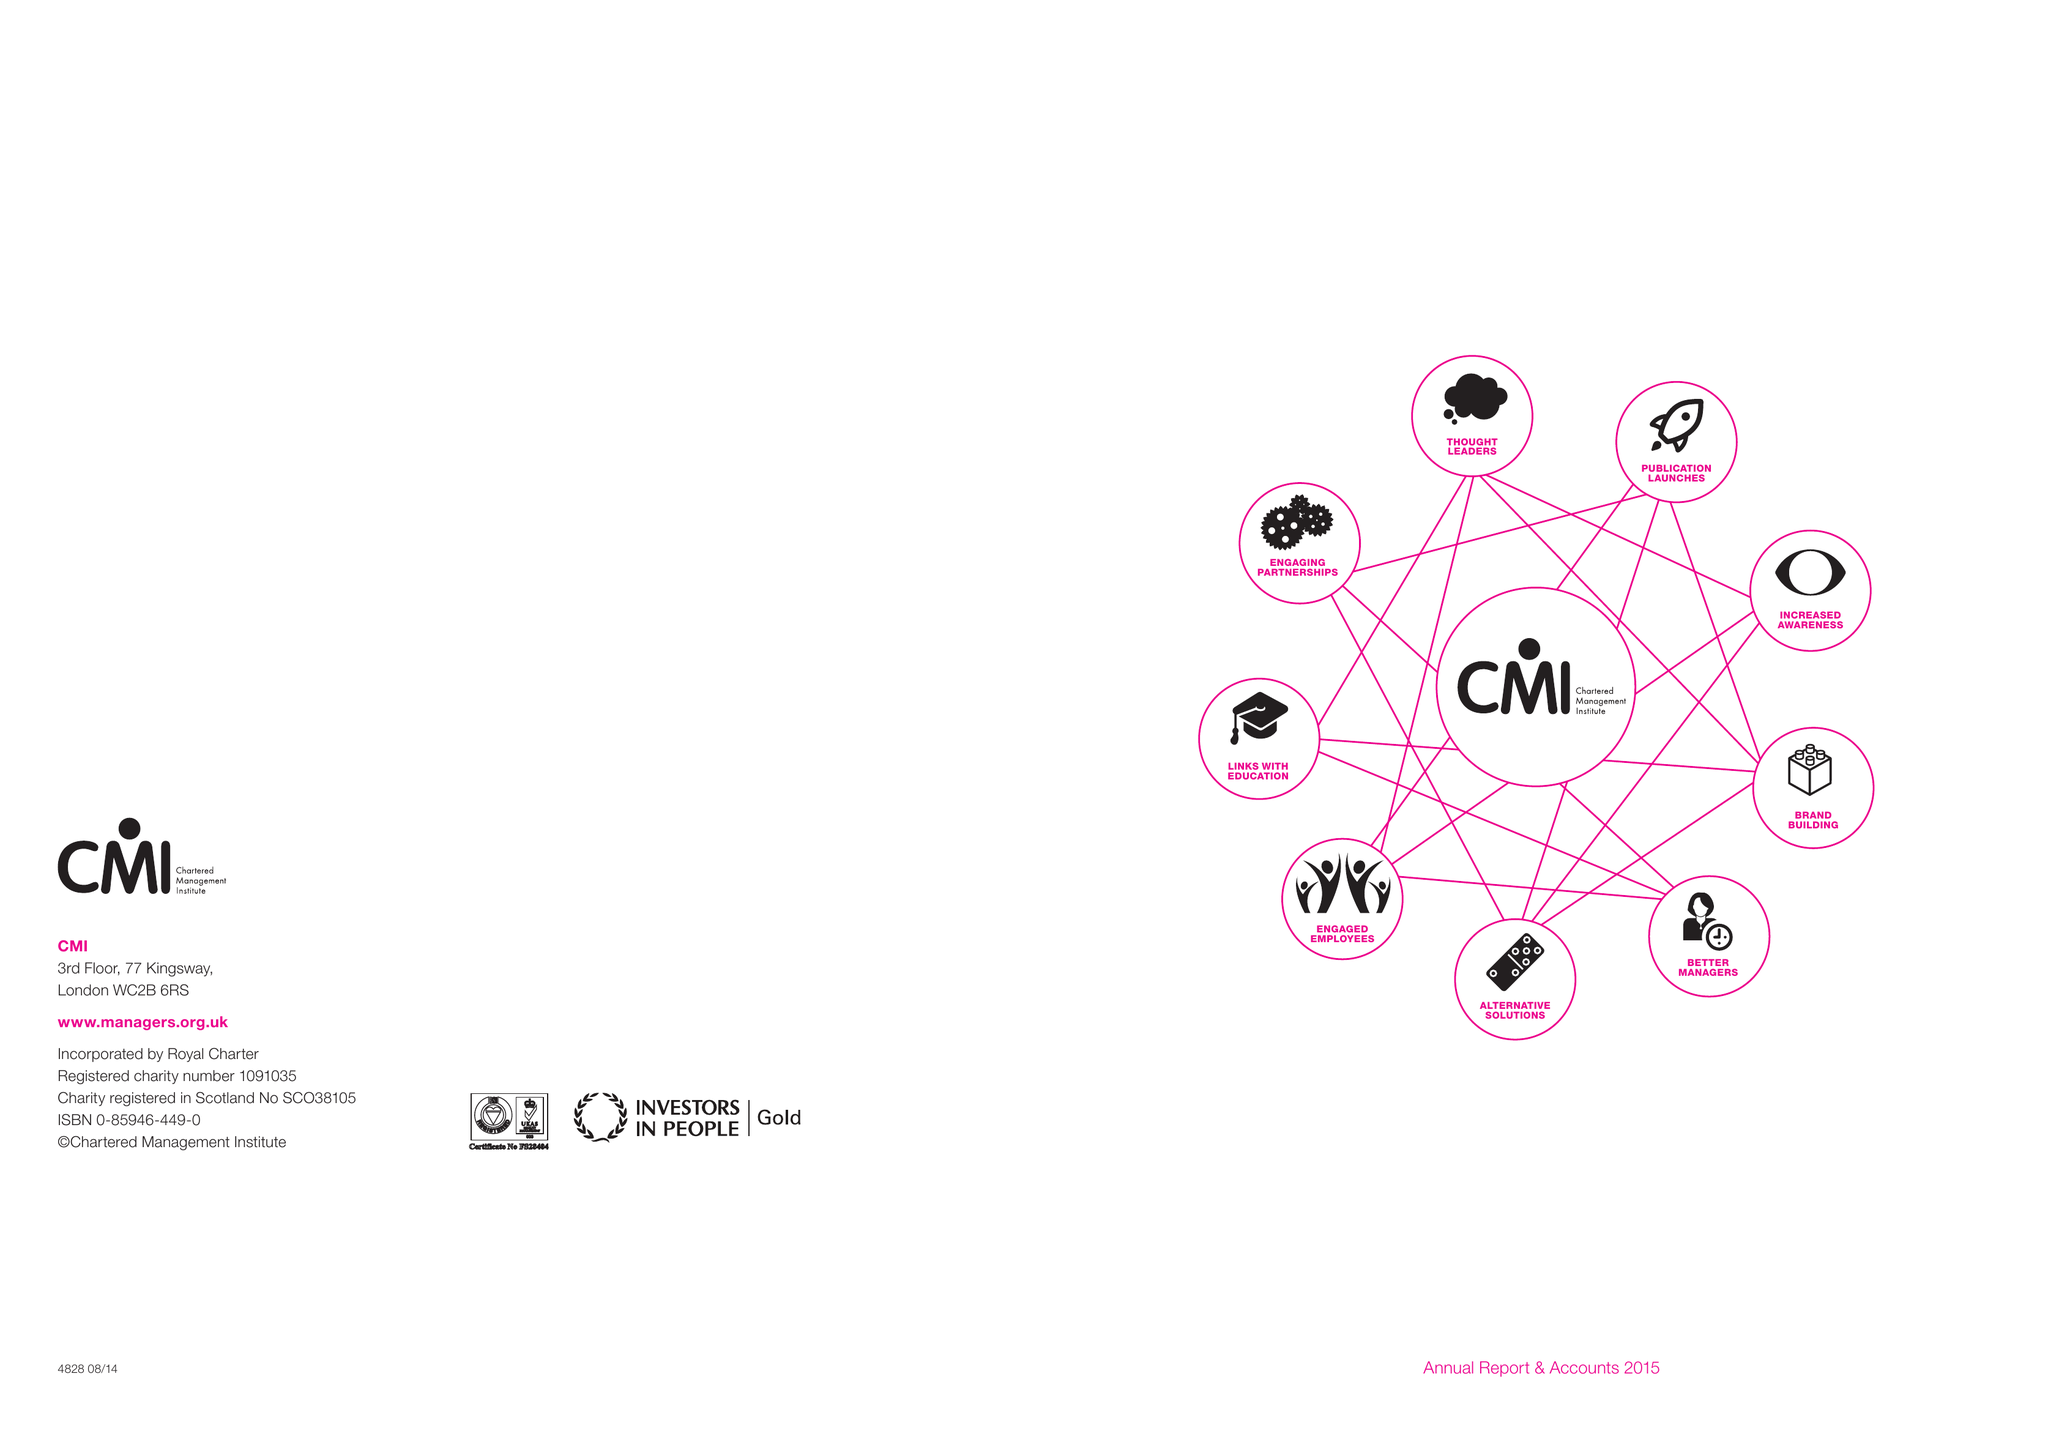What is the value for the address__post_town?
Answer the question using a single word or phrase. CORBY 